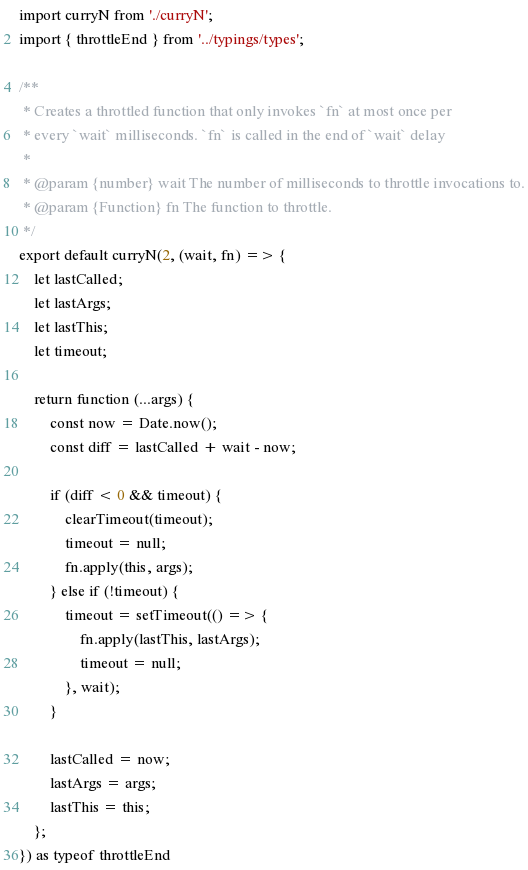Convert code to text. <code><loc_0><loc_0><loc_500><loc_500><_TypeScript_>import curryN from './curryN';
import { throttleEnd } from '../typings/types';

/**
 * Creates a throttled function that only invokes `fn` at most once per
 * every `wait` milliseconds. `fn` is called in the end of `wait` delay
 *
 * @param {number} wait The number of milliseconds to throttle invocations to.
 * @param {Function} fn The function to throttle.
 */
export default curryN(2, (wait, fn) => {
    let lastCalled;
    let lastArgs;
    let lastThis;
    let timeout;

    return function (...args) {
        const now = Date.now();
        const diff = lastCalled + wait - now;

        if (diff < 0 && timeout) {
            clearTimeout(timeout);
            timeout = null;
            fn.apply(this, args);
        } else if (!timeout) {
            timeout = setTimeout(() => {
                fn.apply(lastThis, lastArgs);
                timeout = null;
            }, wait);
        }

        lastCalled = now;
        lastArgs = args;
        lastThis = this;
    };
}) as typeof throttleEnd
</code> 